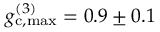Convert formula to latex. <formula><loc_0><loc_0><loc_500><loc_500>g _ { c , \max } ^ { ( 3 ) } = 0 . 9 \pm 0 . 1</formula> 